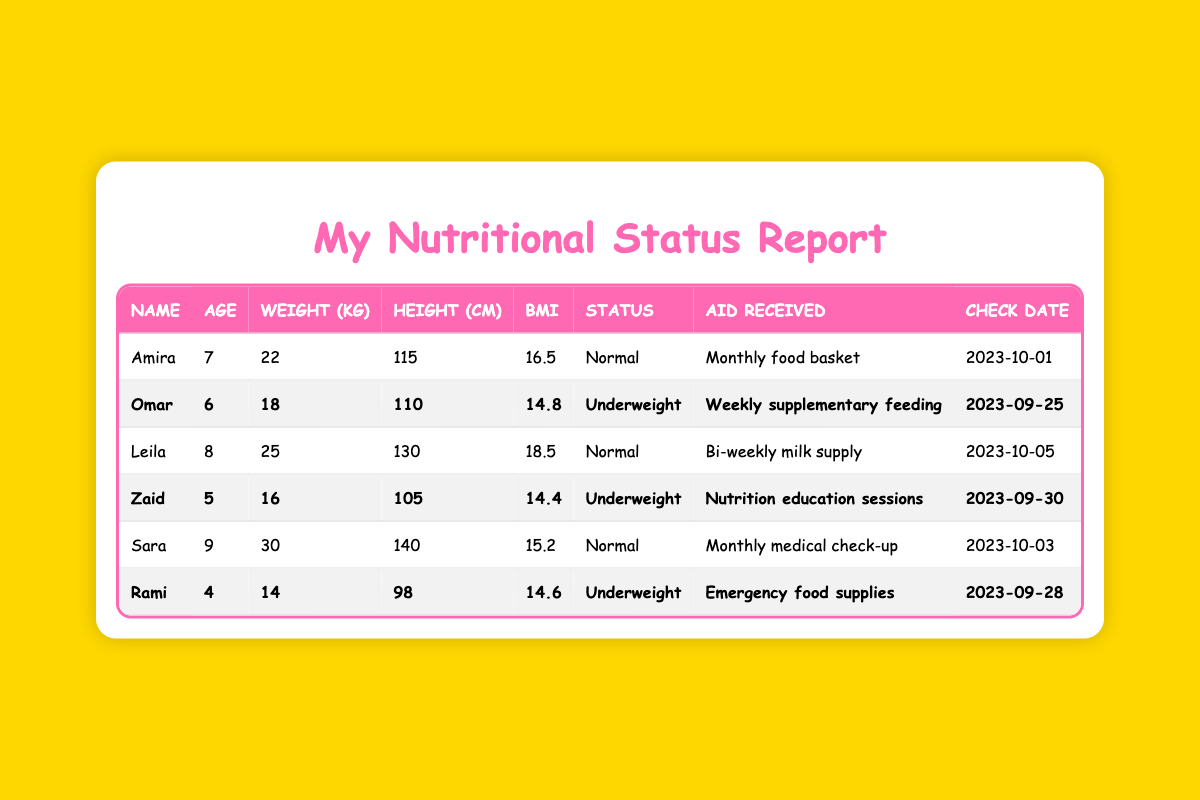What is the nutritional status of Amira? Amira's nutritional status is listed in the table under "NutritionalStatus" and it shows "Normal".
Answer: Normal How much does Omar weigh? Omar's weight is directly given in the "Weight(kg)" column, which shows 18 kg.
Answer: 18 kg Who received a bi-weekly milk supply? The table has a "Name" column where Leila is listed next to "Bi-weekly milk supply" under "Aid Received".
Answer: Leila What is the age of the child with the lowest BMI? The lowest BMI in the table is 14.4, which corresponds to Zaid who is 5 years old.
Answer: 5 How many children are categorized as underweight? Looking at the "NutritionalStatus" column, there are 3 occurrences of "Underweight" among the 6 entries.
Answer: 3 Is Sara receiving a food basket? The "Aid Received" for Sara is "Monthly medical check-up", and not a food basket. Therefore, the answer is no.
Answer: No What is the average weight of all the children listed? The weights are 22, 18, 25, 16, 30, and 14 kg. The sum is 125 kg, and there are 6 children, so the average is 125/6 approximately 20.83 kg.
Answer: 20.83 kg Which child is the oldest and what aid do they receive? Looking through the ages, Sara is the oldest at 9 years and receives a "Monthly medical check-up".
Answer: Sara, Monthly medical check-up How many children are older than 6 years? In the age column, we see Leila (8) and Sara (9) as the only children older than 6. Therefore, there are 2 children.
Answer: 2 What is the height difference between the tallest and shortest children? The tallest child, Sara, is 140 cm tall, and the shortest child, Rami, is 98 cm tall. The difference is 140 - 98 = 42 cm.
Answer: 42 cm 